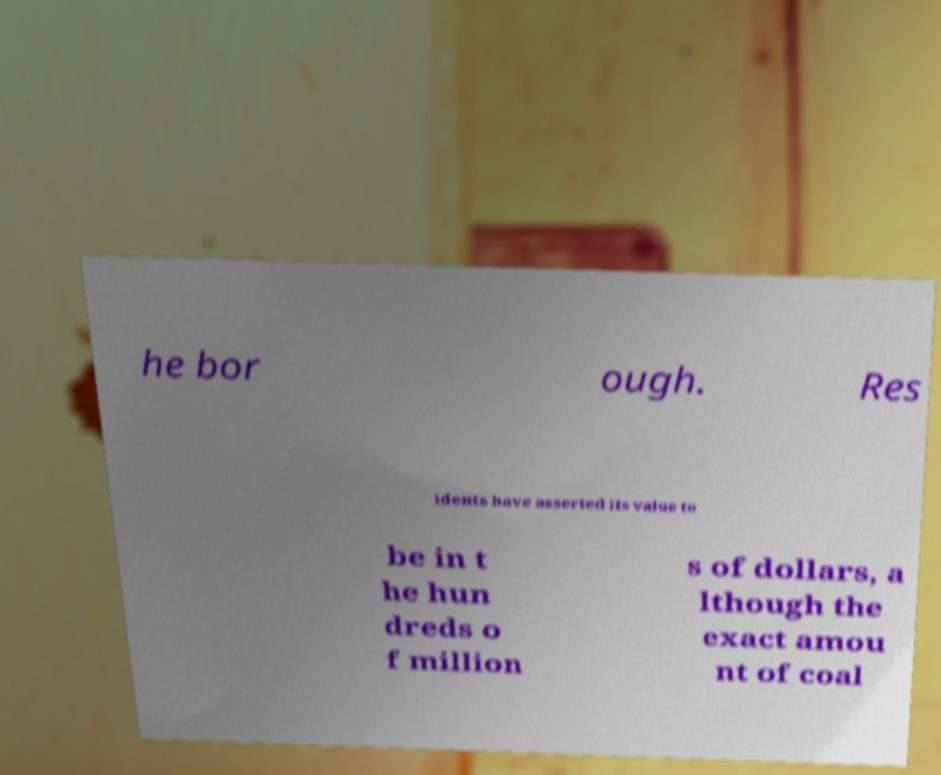Could you extract and type out the text from this image? he bor ough. Res idents have asserted its value to be in t he hun dreds o f million s of dollars, a lthough the exact amou nt of coal 